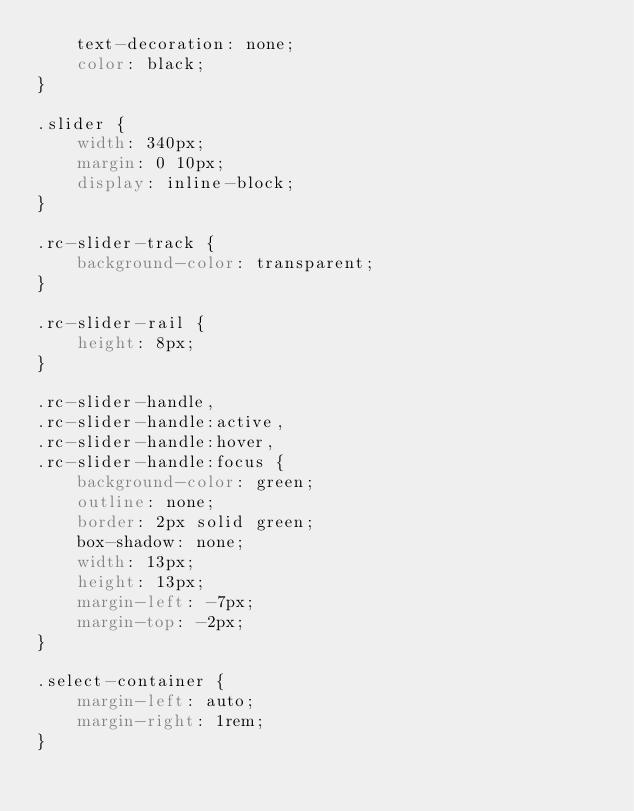Convert code to text. <code><loc_0><loc_0><loc_500><loc_500><_CSS_>	text-decoration: none;
	color: black;
}

.slider {
	width: 340px;
	margin: 0 10px;
	display: inline-block;
}

.rc-slider-track {
	background-color: transparent;
}

.rc-slider-rail {
	height: 8px;
}

.rc-slider-handle,
.rc-slider-handle:active,
.rc-slider-handle:hover,
.rc-slider-handle:focus {
	background-color: green;
	outline: none;
	border: 2px solid green;
	box-shadow: none;
	width: 13px;
	height: 13px;
	margin-left: -7px;
	margin-top: -2px;
}

.select-container {
	margin-left: auto;
	margin-right: 1rem;
}
</code> 